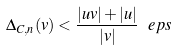<formula> <loc_0><loc_0><loc_500><loc_500>\Delta _ { C , n } ( v ) < \frac { | u v | + | u | } { | v | } \ e p s</formula> 